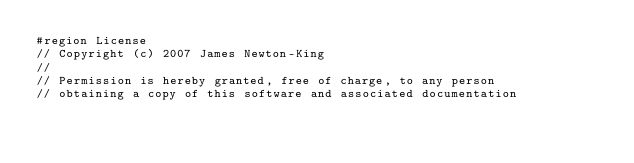<code> <loc_0><loc_0><loc_500><loc_500><_C#_>#region License
// Copyright (c) 2007 James Newton-King
//
// Permission is hereby granted, free of charge, to any person
// obtaining a copy of this software and associated documentation</code> 